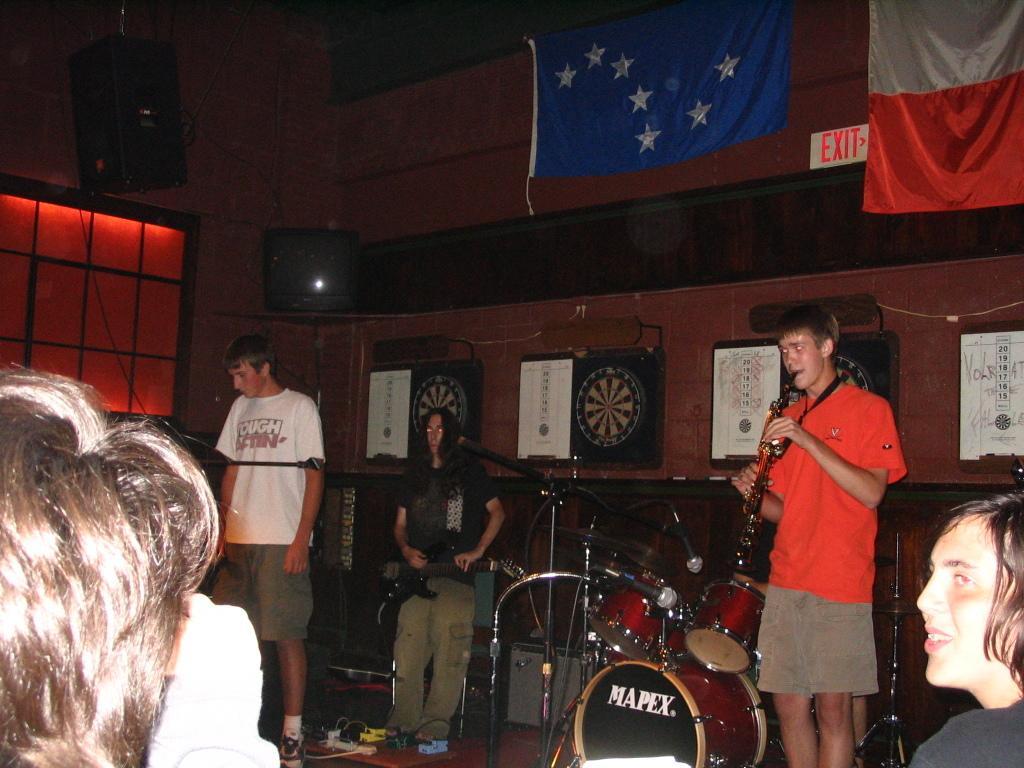How would you summarize this image in a sentence or two? In this picture it seems like a musical performance by three persons, some are the right person in the red dress holding a trumpet in front of there are drums. In the background there is a flag hanging from the ceiling. 